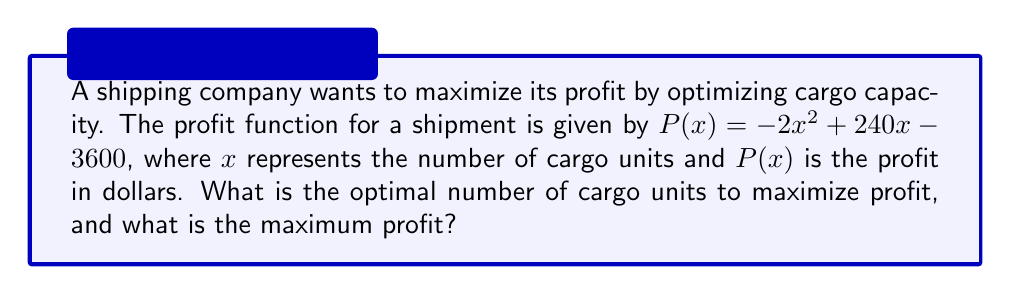Can you solve this math problem? To solve this problem, we need to find the vertex of the quadratic function, which represents the maximum point.

1) The profit function is in the form of a quadratic equation:
   $P(x) = -2x^2 + 240x - 3600$

2) For a quadratic function in the form $f(x) = ax^2 + bx + c$, the x-coordinate of the vertex is given by $x = -\frac{b}{2a}$

3) In this case, $a = -2$ and $b = 240$. So:
   $x = -\frac{240}{2(-2)} = \frac{240}{4} = 60$

4) The optimal number of cargo units is 60.

5) To find the maximum profit, we substitute $x = 60$ into the original function:
   $P(60) = -2(60)^2 + 240(60) - 3600$
   $= -2(3600) + 14400 - 3600$
   $= -7200 + 14400 - 3600$
   $= 3600$

Therefore, the maximum profit is $3600.
Answer: The optimal number of cargo units is 60, and the maximum profit is $3600. 